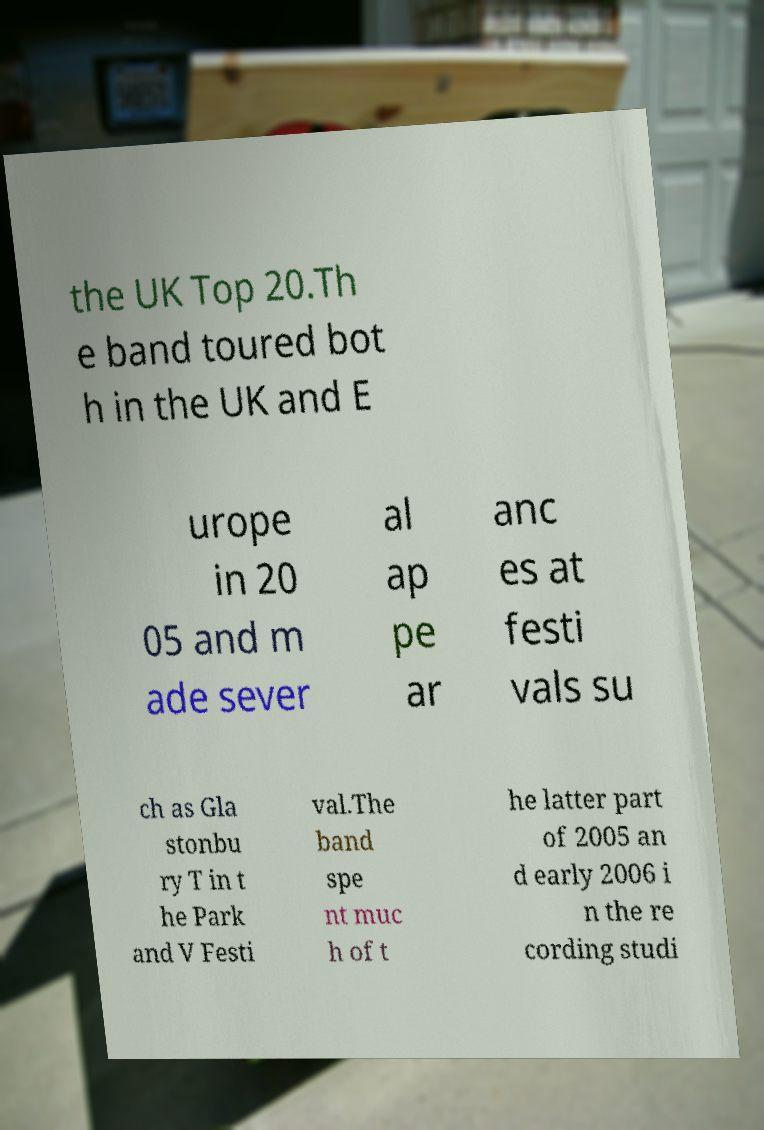Can you accurately transcribe the text from the provided image for me? the UK Top 20.Th e band toured bot h in the UK and E urope in 20 05 and m ade sever al ap pe ar anc es at festi vals su ch as Gla stonbu ry T in t he Park and V Festi val.The band spe nt muc h of t he latter part of 2005 an d early 2006 i n the re cording studi 